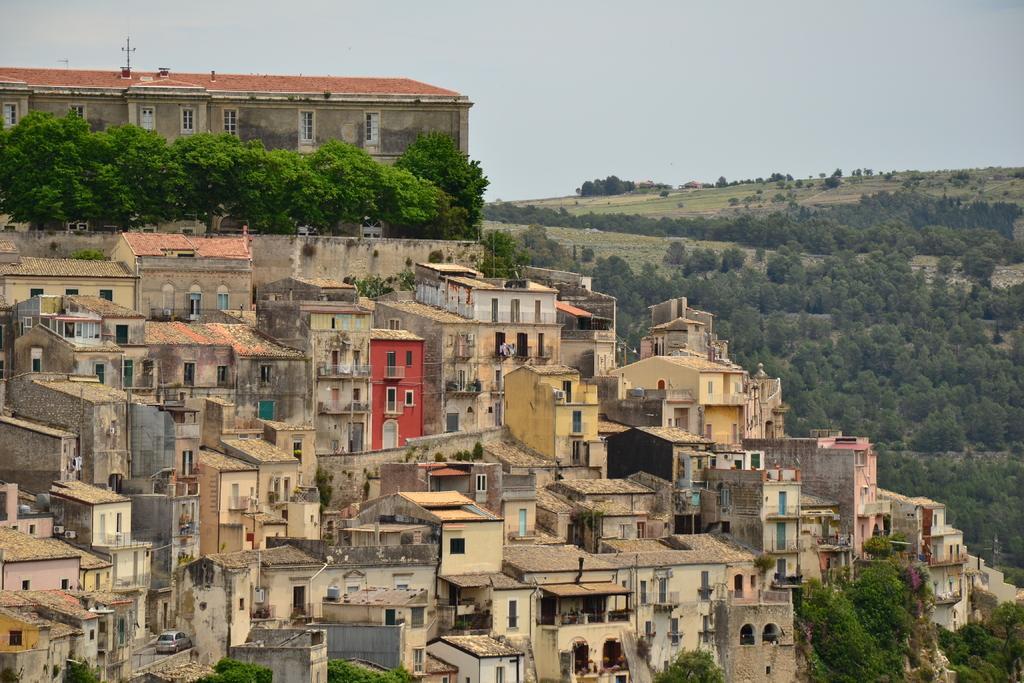How would you summarize this image in a sentence or two? The picture consists of many buildings and houses on the mountain and there are plants , trees which are surrounded the hill and there is a sky. 